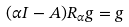<formula> <loc_0><loc_0><loc_500><loc_500>( \alpha I - A ) R _ { \alpha } g = g</formula> 